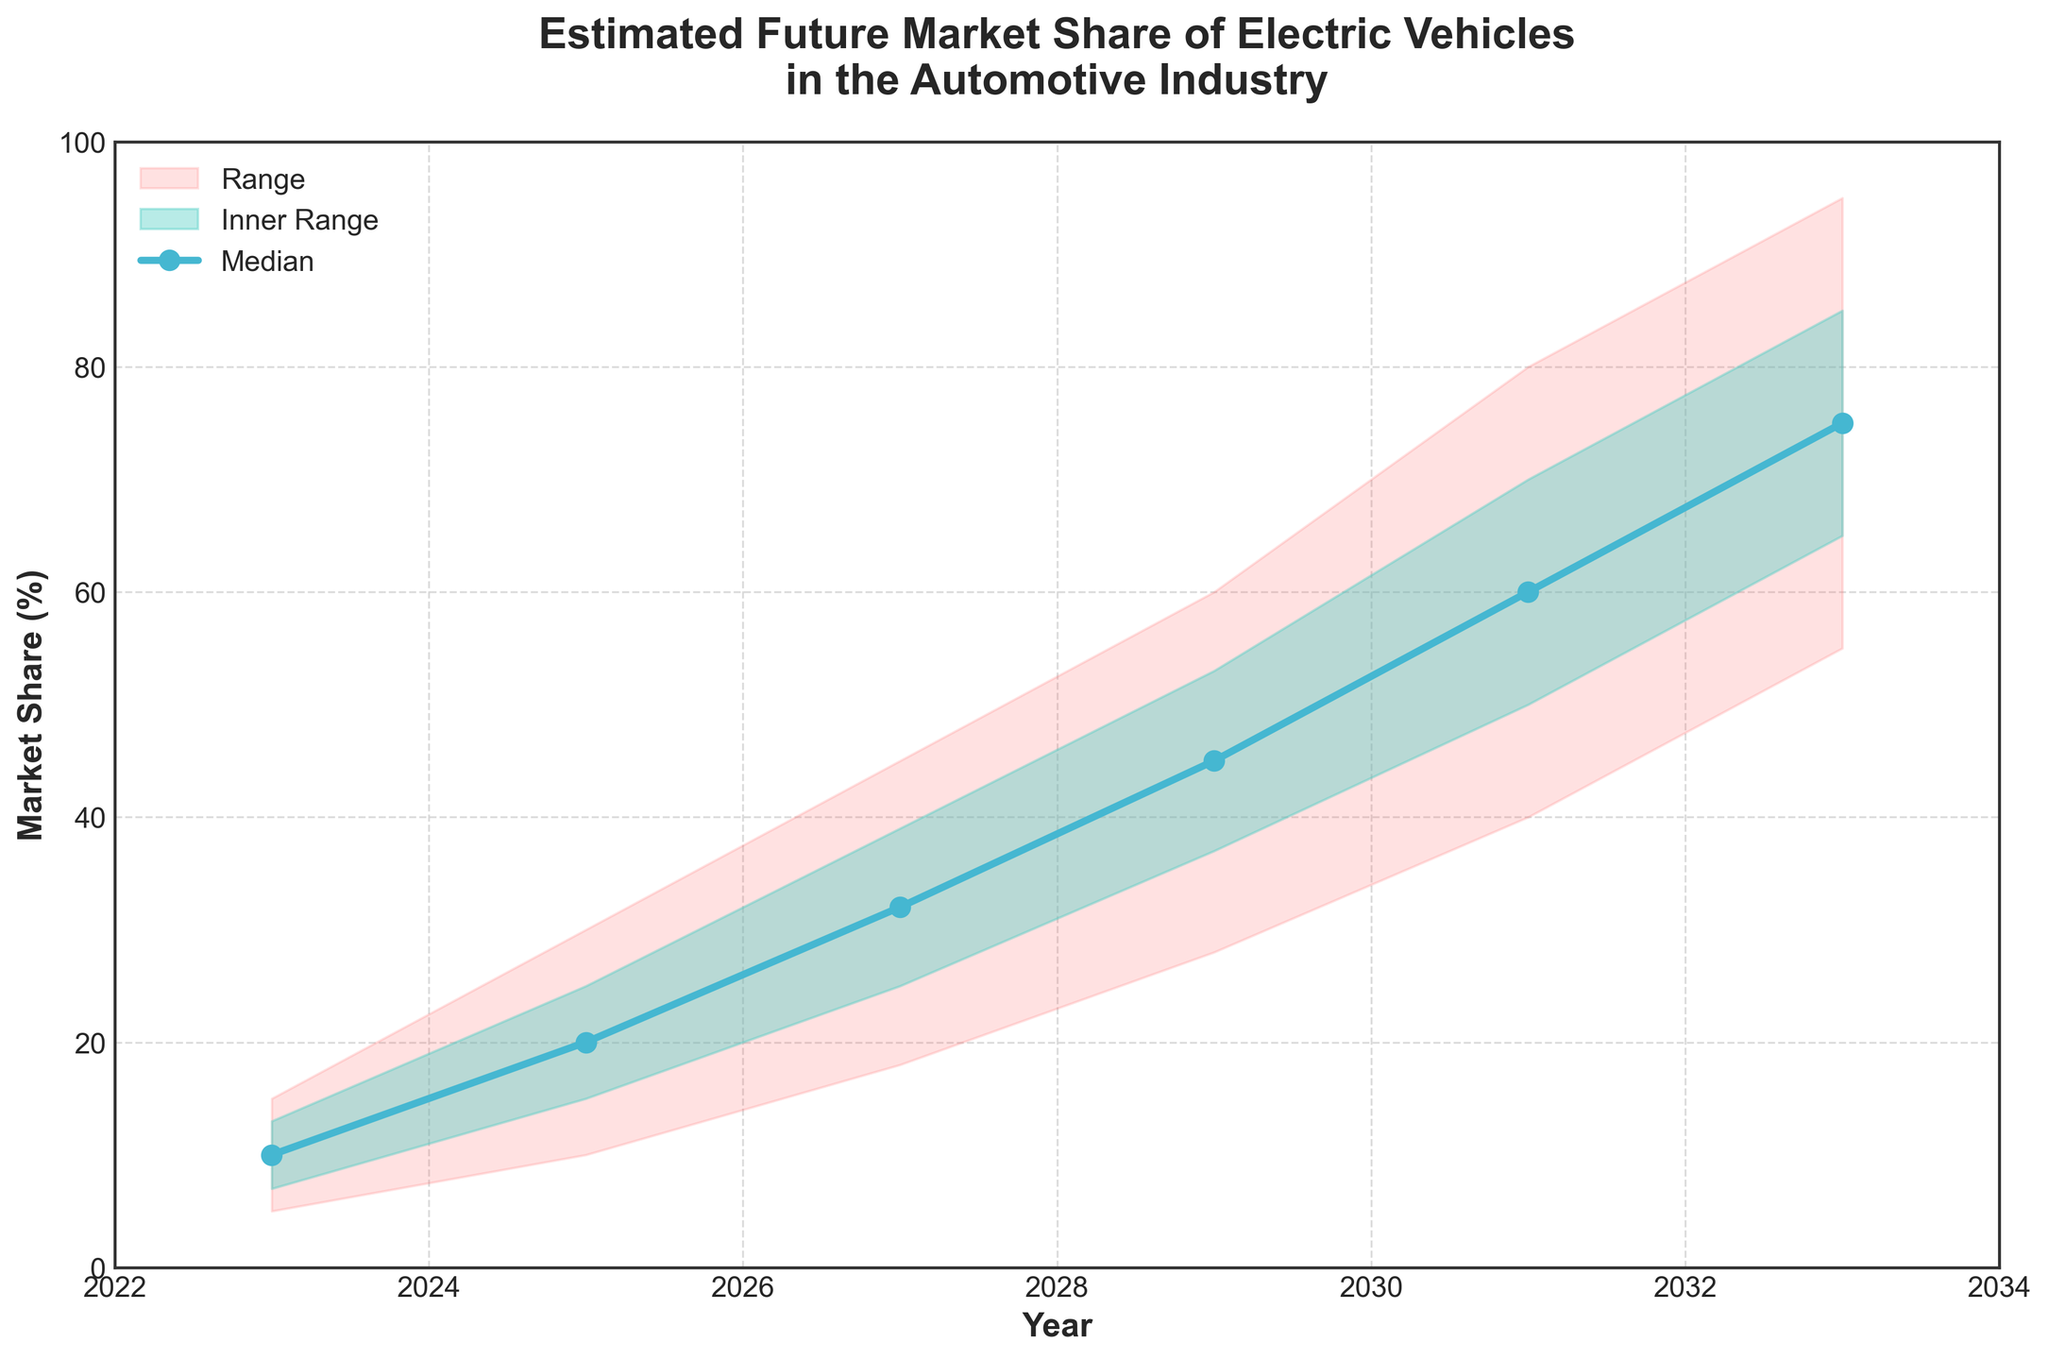What is the range of market share values in 2023? The range of market share values in 2023 is indicated by the 'Low' and 'High' values. The 'Low' value is 5, and the 'High' value is 15.
Answer: 5 to 15 What is the expected median market share of electric vehicles in 2027? The expected median market share of electric vehicles in 2027 is represented by the 'Mid' value on the plot. According to the data, the 'Mid' value is 32.
Answer: 32 By how much does the median market share increase from 2023 to 2025? The median market share in 2023 is 10, and in 2025 it is 20. The increase is 20 - 10 = 10.
Answer: 10 What year shows the highest 'High' estimated market share? The 'High' estimated market share is at its peak in the year 2033, where the value reaches 95.
Answer: 2033 Which range is represented by the red shaded area? The red shaded area represents the range between the 'Low' and 'High' values across the years. For example, in 2023, it spans from 5 to 15.
Answer: Low to High How does the 'Inner Range' (Low-Mid to Mid-High) for 2029 compare to that for 2025? The 'Inner Range' for 2029 is from 37 to 53, so its span is 53 - 37 = 16. For 2025, the range is from 15 to 25, making its span 25 - 15 = 10. Thus, the range for 2029 is wider.
Answer: Wider in 2029 Between which years is there the biggest increase in 'Mid' market share? We need to compare the increases in the 'Mid' market share across the years. The largest increase is from 2029 (45) to 2031 (60), with an increase of 60 - 45 = 15.
Answer: From 2029 to 2031 By how much does the 'High' market share value increase from 2025 to 2033? The 'High' market share value in 2025 is 30, and in 2033, it is 95. The increase is 95 - 30 = 65.
Answer: 65 How does the 'Low-Mid' value for 2031 compare with the 'Low-Mid' value for 2023? The 'Low-Mid' value for 2031 is 50, while for 2023, it is 7. The 2031 value is significantly higher.
Answer: Significantly higher in 2031 What is the average 'Mid' market share over the years shown? The 'Mid' market share values are 10, 20, 32, 45, 60, 75. The sum is 10 + 20 + 32 + 45 + 60 + 75 = 242, and the average is 242 / 6 ≈ 40.33.
Answer: Approximately 40.33 